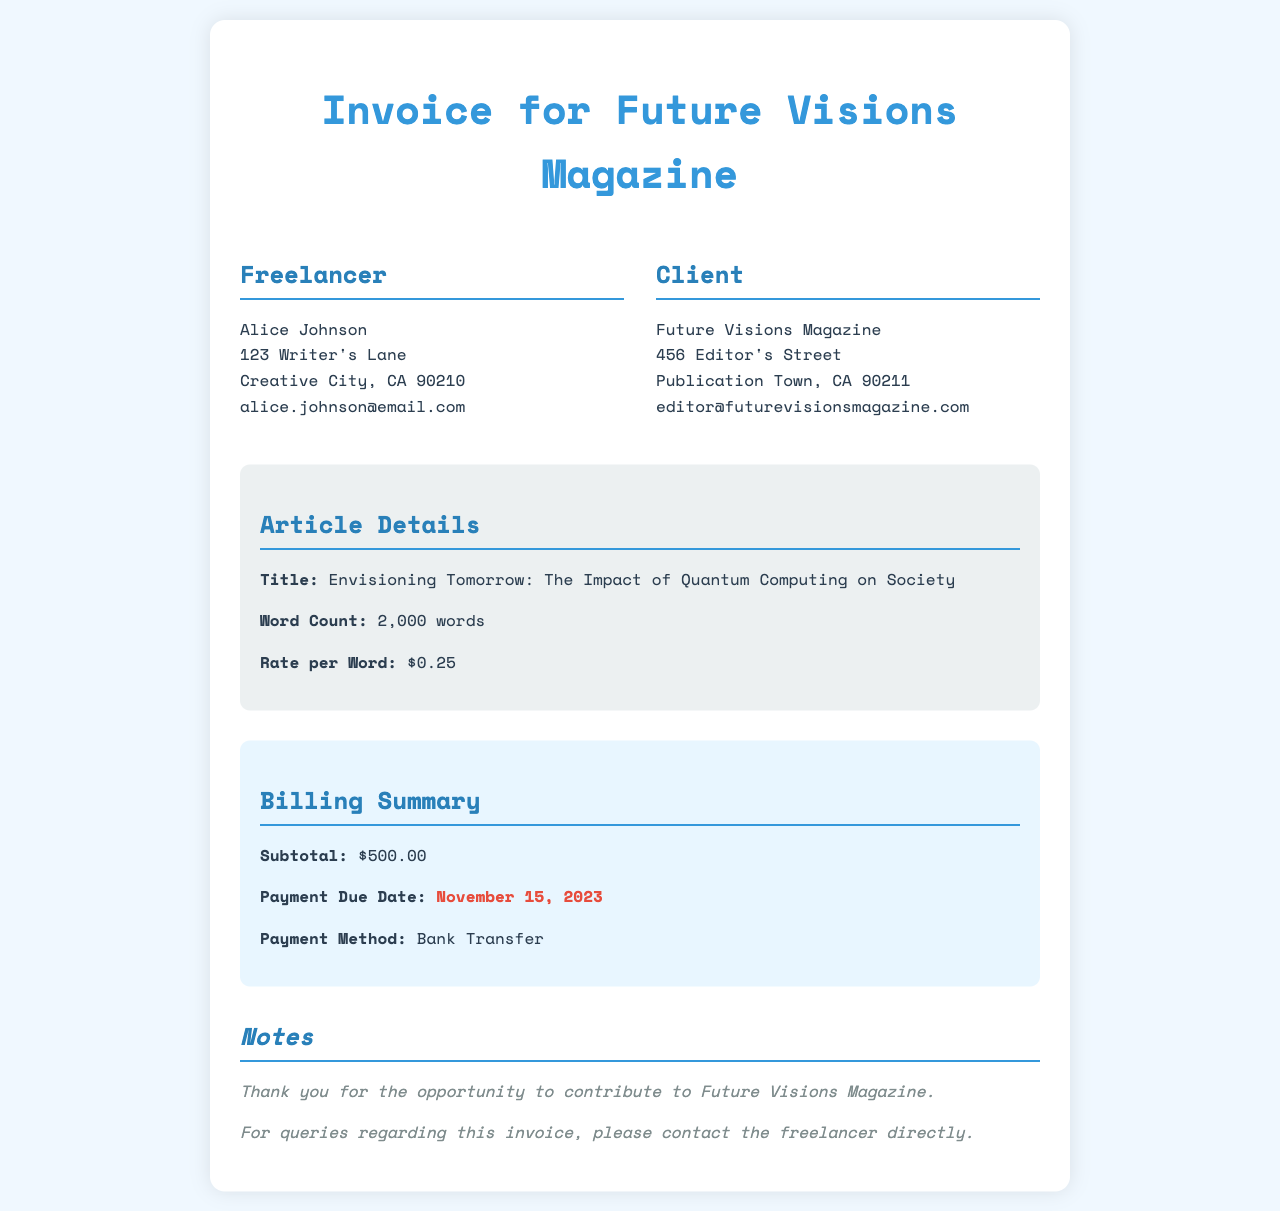What is the title of the article? The title of the article is mentioned in the article details section, which is "Envisioning Tomorrow: The Impact of Quantum Computing on Society".
Answer: Envisioning Tomorrow: The Impact of Quantum Computing on Society What is the total word count of the article? The total word count is stated in the article details section as 2,000 words.
Answer: 2,000 words What is the rate per word for the article? The rate per word is specified in the article details section, which indicates $0.25.
Answer: $0.25 What is the subtotal amount due for the article? The subtotal amount is found in the billing summary section, which shows $500.00.
Answer: $500.00 When is the payment due date? The due date for payment is highlighted in the billing summary section as November 15, 2023.
Answer: November 15, 2023 What is the payment method mentioned in the invoice? The payment method is stated in the billing summary section, which is Bank Transfer.
Answer: Bank Transfer Who is the freelancer for this article? The freelancer's name is listed in the invoice details; it is Alice Johnson.
Answer: Alice Johnson What is the client's name? The client's name is listed in the invoice details, which is Future Visions Magazine.
Answer: Future Visions Magazine What background color is used for the article details section? The background color for the article details section is mentioned to be a light gray (#ecf0f1).
Answer: Light gray 